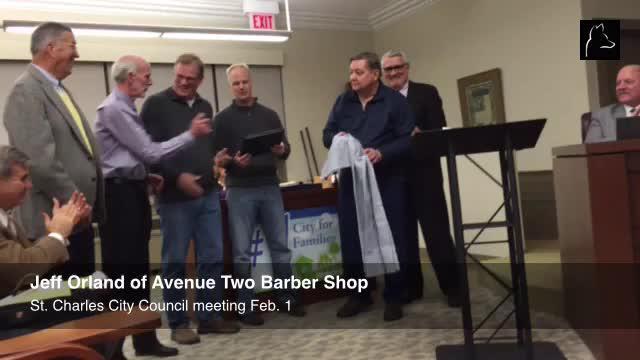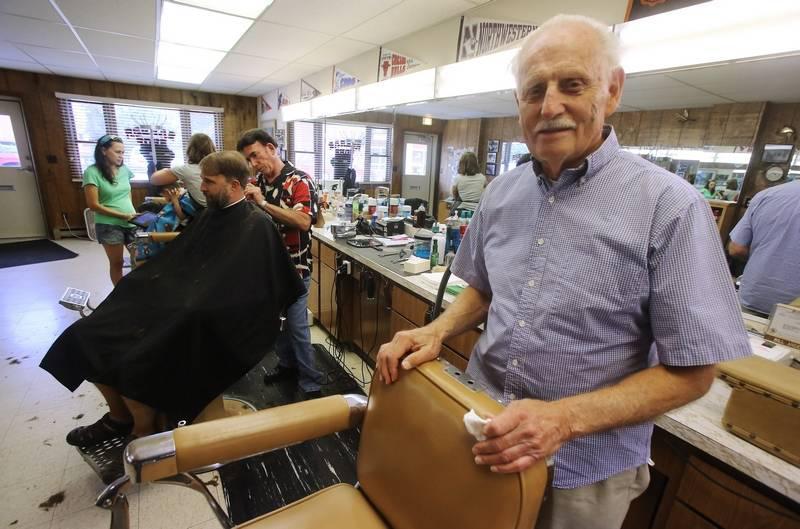The first image is the image on the left, the second image is the image on the right. Given the left and right images, does the statement "In one of the images, people are outside the storefront under the sign." hold true? Answer yes or no. No. The first image is the image on the left, the second image is the image on the right. Considering the images on both sides, is "One of the images shows a group of exactly women with arms folded." valid? Answer yes or no. No. 